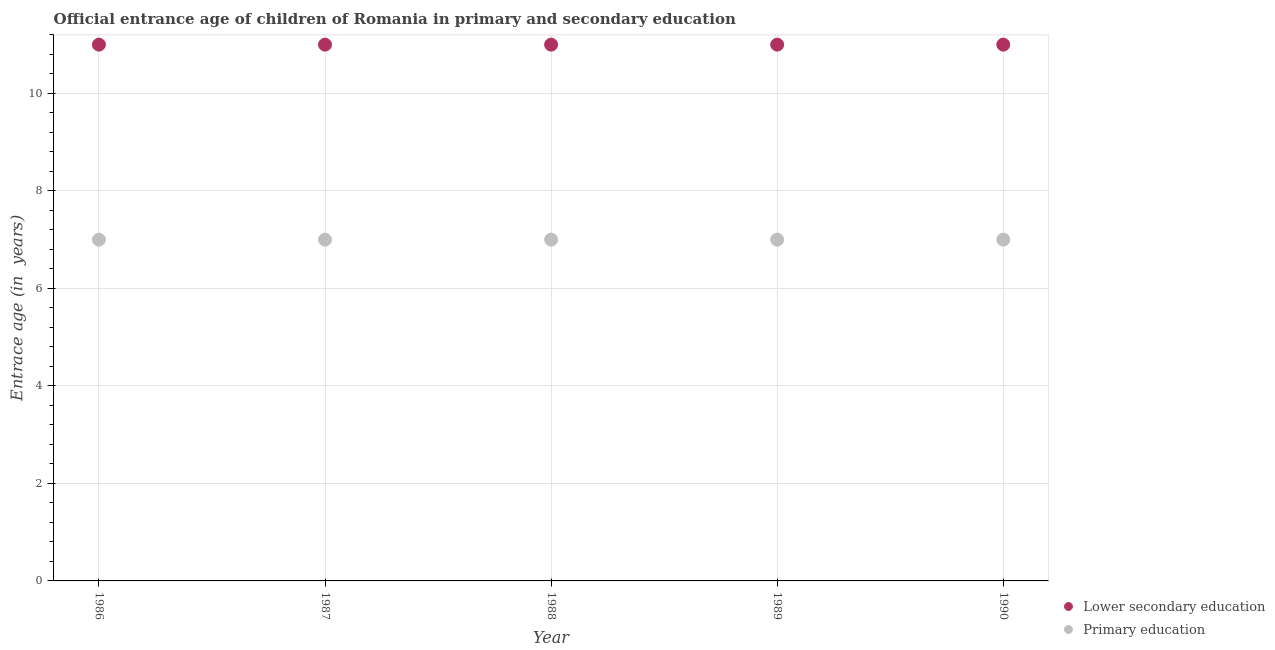What is the entrance age of children in lower secondary education in 1990?
Keep it short and to the point. 11. Across all years, what is the maximum entrance age of children in lower secondary education?
Offer a very short reply. 11. Across all years, what is the minimum entrance age of children in lower secondary education?
Offer a very short reply. 11. In which year was the entrance age of children in lower secondary education maximum?
Offer a very short reply. 1986. In which year was the entrance age of children in lower secondary education minimum?
Provide a short and direct response. 1986. What is the total entrance age of children in lower secondary education in the graph?
Make the answer very short. 55. What is the difference between the entrance age of children in lower secondary education in 1989 and the entrance age of chiildren in primary education in 1986?
Provide a short and direct response. 4. What is the average entrance age of chiildren in primary education per year?
Give a very brief answer. 7. In the year 1987, what is the difference between the entrance age of children in lower secondary education and entrance age of chiildren in primary education?
Ensure brevity in your answer.  4. In how many years, is the entrance age of chiildren in primary education greater than 6 years?
Offer a very short reply. 5. What is the difference between the highest and the second highest entrance age of chiildren in primary education?
Make the answer very short. 0. In how many years, is the entrance age of chiildren in primary education greater than the average entrance age of chiildren in primary education taken over all years?
Your response must be concise. 0. Is the sum of the entrance age of children in lower secondary education in 1988 and 1990 greater than the maximum entrance age of chiildren in primary education across all years?
Provide a succinct answer. Yes. Does the entrance age of chiildren in primary education monotonically increase over the years?
Provide a succinct answer. No. Is the entrance age of chiildren in primary education strictly less than the entrance age of children in lower secondary education over the years?
Offer a very short reply. Yes. Does the graph contain any zero values?
Offer a terse response. No. What is the title of the graph?
Provide a succinct answer. Official entrance age of children of Romania in primary and secondary education. What is the label or title of the X-axis?
Your response must be concise. Year. What is the label or title of the Y-axis?
Provide a short and direct response. Entrace age (in  years). What is the Entrace age (in  years) of Lower secondary education in 1986?
Offer a very short reply. 11. What is the Entrace age (in  years) of Lower secondary education in 1987?
Your answer should be compact. 11. What is the Entrace age (in  years) of Primary education in 1989?
Make the answer very short. 7. What is the Entrace age (in  years) in Lower secondary education in 1990?
Offer a terse response. 11. Across all years, what is the maximum Entrace age (in  years) of Lower secondary education?
Make the answer very short. 11. What is the total Entrace age (in  years) of Primary education in the graph?
Give a very brief answer. 35. What is the difference between the Entrace age (in  years) in Primary education in 1986 and that in 1987?
Offer a very short reply. 0. What is the difference between the Entrace age (in  years) of Primary education in 1986 and that in 1988?
Ensure brevity in your answer.  0. What is the difference between the Entrace age (in  years) in Lower secondary education in 1986 and that in 1990?
Your answer should be compact. 0. What is the difference between the Entrace age (in  years) of Primary education in 1987 and that in 1988?
Your answer should be very brief. 0. What is the difference between the Entrace age (in  years) in Primary education in 1987 and that in 1990?
Offer a very short reply. 0. What is the difference between the Entrace age (in  years) of Lower secondary education in 1988 and that in 1990?
Make the answer very short. 0. What is the difference between the Entrace age (in  years) of Primary education in 1989 and that in 1990?
Give a very brief answer. 0. What is the difference between the Entrace age (in  years) of Lower secondary education in 1986 and the Entrace age (in  years) of Primary education in 1987?
Your answer should be very brief. 4. What is the difference between the Entrace age (in  years) of Lower secondary education in 1986 and the Entrace age (in  years) of Primary education in 1988?
Give a very brief answer. 4. What is the difference between the Entrace age (in  years) of Lower secondary education in 1986 and the Entrace age (in  years) of Primary education in 1990?
Your answer should be very brief. 4. What is the difference between the Entrace age (in  years) of Lower secondary education in 1987 and the Entrace age (in  years) of Primary education in 1988?
Make the answer very short. 4. What is the difference between the Entrace age (in  years) in Lower secondary education in 1987 and the Entrace age (in  years) in Primary education in 1990?
Offer a terse response. 4. In the year 1986, what is the difference between the Entrace age (in  years) of Lower secondary education and Entrace age (in  years) of Primary education?
Your answer should be very brief. 4. In the year 1987, what is the difference between the Entrace age (in  years) in Lower secondary education and Entrace age (in  years) in Primary education?
Your answer should be compact. 4. In the year 1988, what is the difference between the Entrace age (in  years) of Lower secondary education and Entrace age (in  years) of Primary education?
Give a very brief answer. 4. In the year 1989, what is the difference between the Entrace age (in  years) of Lower secondary education and Entrace age (in  years) of Primary education?
Keep it short and to the point. 4. What is the ratio of the Entrace age (in  years) in Primary education in 1986 to that in 1987?
Your answer should be compact. 1. What is the ratio of the Entrace age (in  years) in Primary education in 1986 to that in 1988?
Your answer should be compact. 1. What is the ratio of the Entrace age (in  years) in Lower secondary education in 1986 to that in 1989?
Provide a short and direct response. 1. What is the ratio of the Entrace age (in  years) of Primary education in 1986 to that in 1989?
Make the answer very short. 1. What is the ratio of the Entrace age (in  years) of Lower secondary education in 1987 to that in 1988?
Give a very brief answer. 1. What is the ratio of the Entrace age (in  years) of Primary education in 1987 to that in 1988?
Offer a terse response. 1. What is the ratio of the Entrace age (in  years) of Lower secondary education in 1987 to that in 1989?
Ensure brevity in your answer.  1. What is the ratio of the Entrace age (in  years) in Primary education in 1987 to that in 1989?
Provide a succinct answer. 1. What is the ratio of the Entrace age (in  years) in Lower secondary education in 1987 to that in 1990?
Offer a very short reply. 1. What is the ratio of the Entrace age (in  years) in Primary education in 1988 to that in 1989?
Your answer should be very brief. 1. What is the difference between the highest and the second highest Entrace age (in  years) of Lower secondary education?
Make the answer very short. 0. What is the difference between the highest and the second highest Entrace age (in  years) of Primary education?
Your response must be concise. 0. 